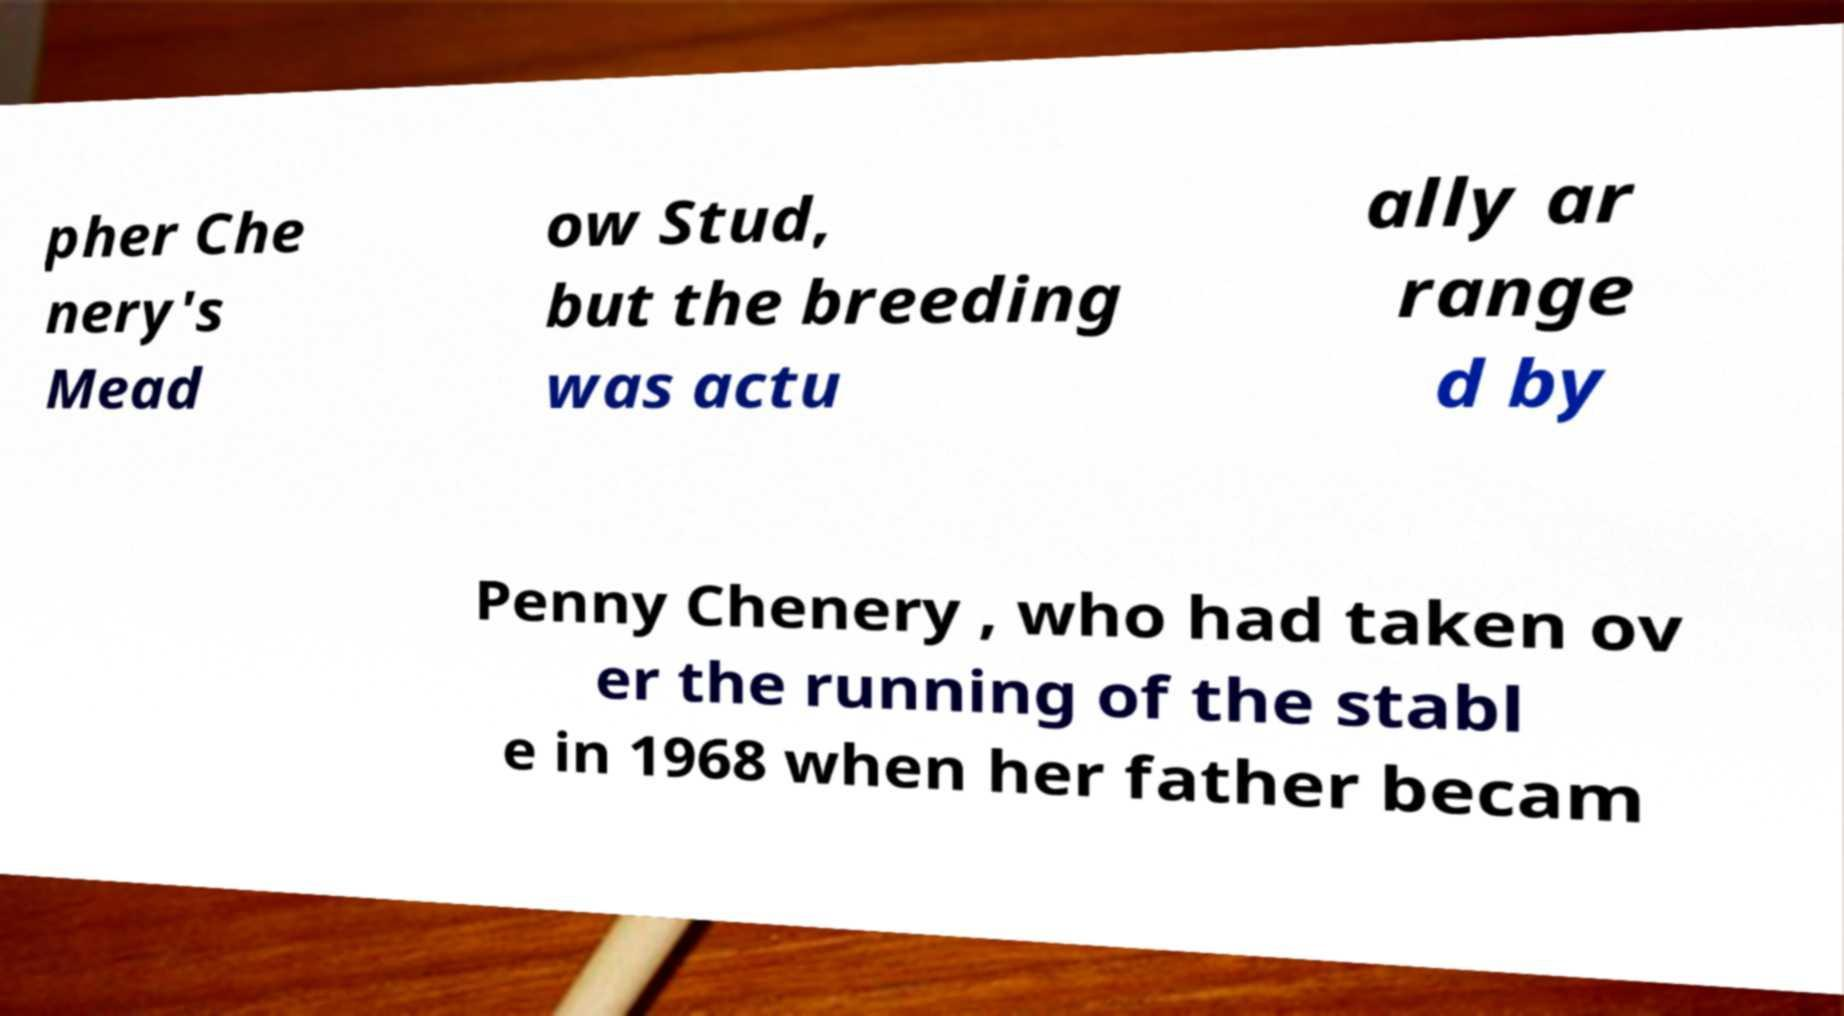Could you assist in decoding the text presented in this image and type it out clearly? pher Che nery's Mead ow Stud, but the breeding was actu ally ar range d by Penny Chenery , who had taken ov er the running of the stabl e in 1968 when her father becam 